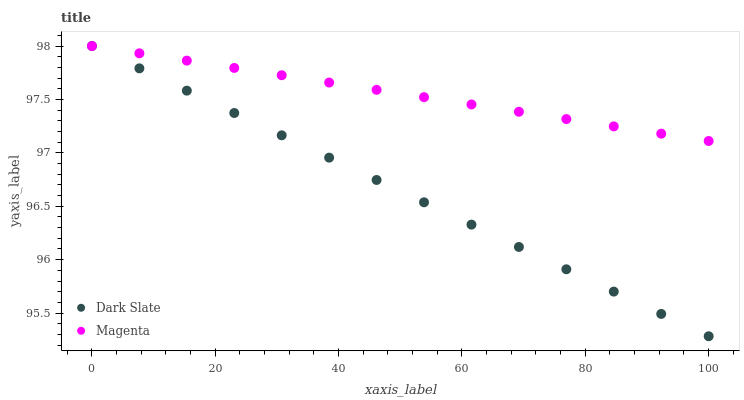Does Dark Slate have the minimum area under the curve?
Answer yes or no. Yes. Does Magenta have the maximum area under the curve?
Answer yes or no. Yes. Does Magenta have the minimum area under the curve?
Answer yes or no. No. Is Dark Slate the smoothest?
Answer yes or no. Yes. Is Magenta the roughest?
Answer yes or no. Yes. Is Magenta the smoothest?
Answer yes or no. No. Does Dark Slate have the lowest value?
Answer yes or no. Yes. Does Magenta have the lowest value?
Answer yes or no. No. Does Magenta have the highest value?
Answer yes or no. Yes. Does Magenta intersect Dark Slate?
Answer yes or no. Yes. Is Magenta less than Dark Slate?
Answer yes or no. No. Is Magenta greater than Dark Slate?
Answer yes or no. No. 